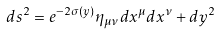<formula> <loc_0><loc_0><loc_500><loc_500>d s ^ { 2 } = e ^ { - 2 \sigma ( y ) } \eta _ { \mu \nu } d x ^ { \mu } d x ^ { \nu } + d y ^ { 2 }</formula> 